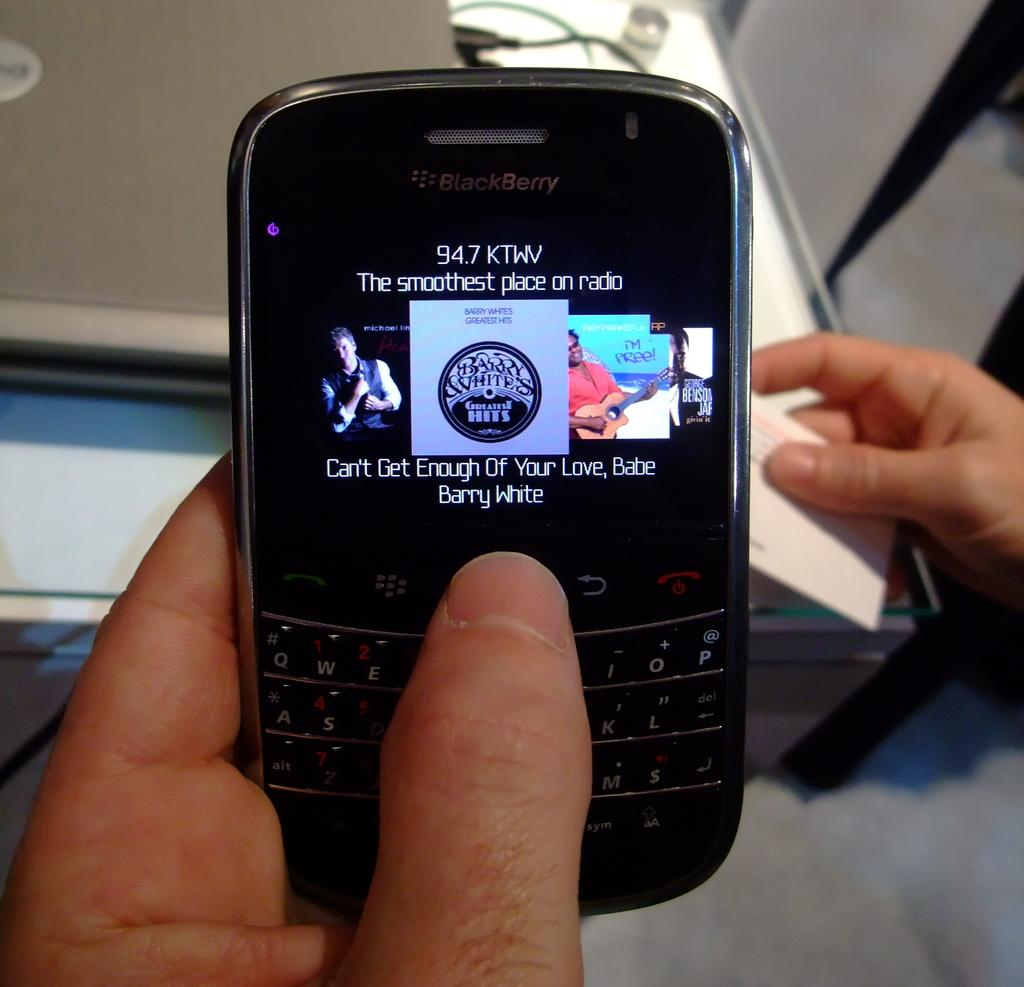<image>
Provide a brief description of the given image. The screen on a phone shows Barry White music. 